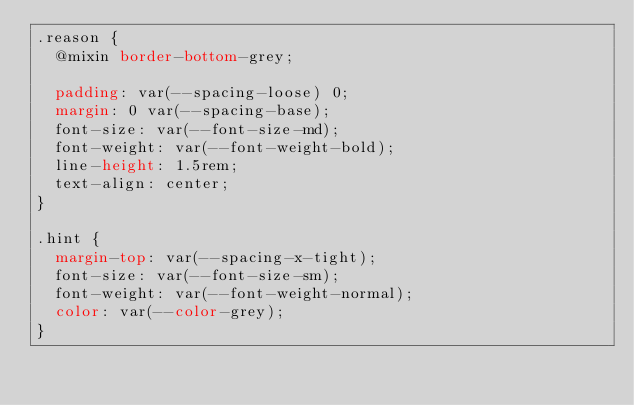<code> <loc_0><loc_0><loc_500><loc_500><_CSS_>.reason {
  @mixin border-bottom-grey;

  padding: var(--spacing-loose) 0;
  margin: 0 var(--spacing-base);
  font-size: var(--font-size-md);
  font-weight: var(--font-weight-bold);
  line-height: 1.5rem;
  text-align: center;
}

.hint {
  margin-top: var(--spacing-x-tight);
  font-size: var(--font-size-sm);
  font-weight: var(--font-weight-normal);
  color: var(--color-grey);
}
</code> 